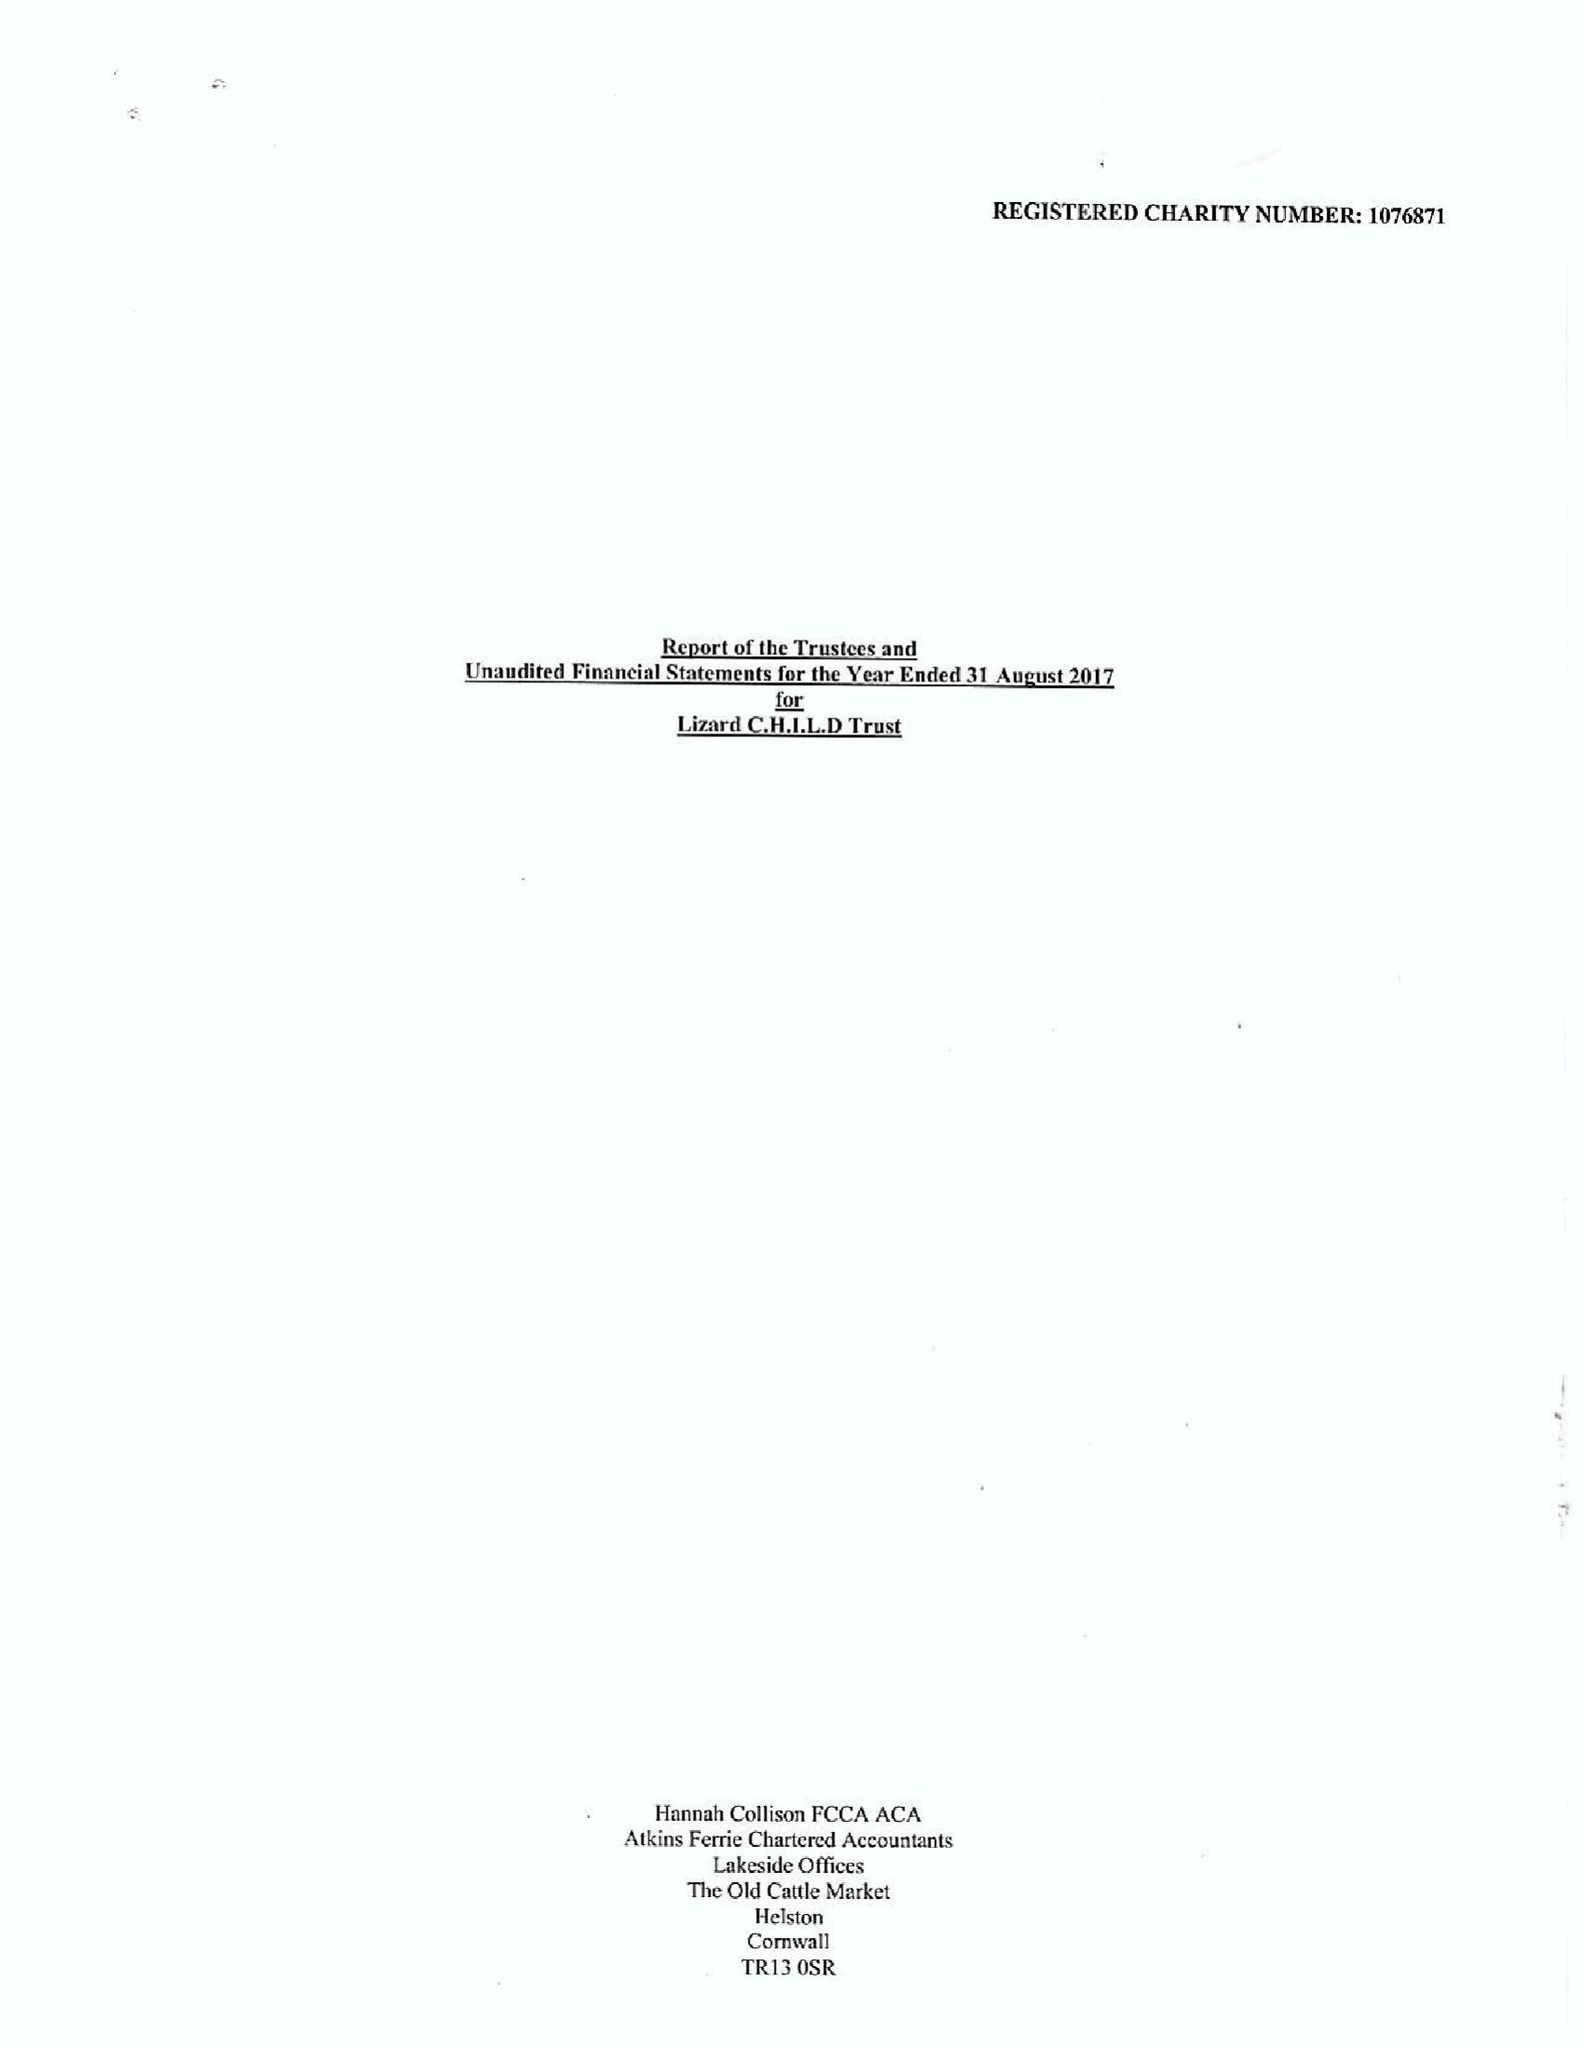What is the value for the address__postcode?
Answer the question using a single word or phrase. TR13 8AR 